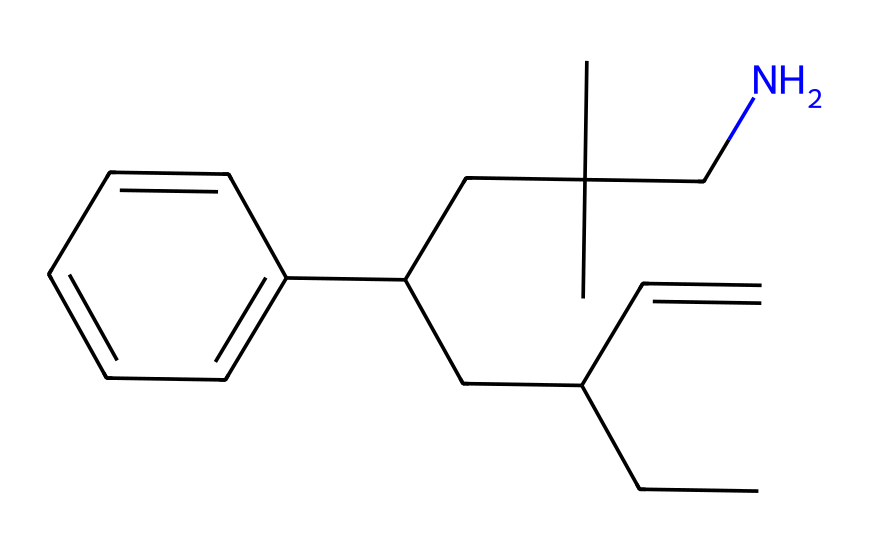What is the total number of carbon atoms in the structure? Count the number of carbon (C) symbols in the SMILES representation, which indicates all the carbon atoms present in the molecular structure. By analyzing the provided SMILES, we find a total of 16 carbon atoms.
Answer: 16 How many nitrogen atoms are present in the molecule? Look for the nitrogen (N) symbols in the SMILES representation. In the provided structure, there is one nitrogen atom present.
Answer: 1 What type of functional group is primarily represented in this structure? Examine the structure to identify the functional groups, particularly looking for double bonds or aromatic rings. The presence of alkenes (C=C) and an aromatic ring (c1ccccc1) indicates that the main functional groups in this structure are alkenes and aromatic compounds.
Answer: alkenes and aromatic How many cycles or rings are present in the molecule? Analyze the structure for any ring closures, which are indicated by the numerical identifiers in SMILES. In this case, the presence of 'c1ccccc1' indicates one cyclic structure (a benzene ring).
Answer: 1 Which part of the molecule contributes to its elasticity? Identify the segments of the molecule that could provide elastic properties, typically found in plastic materials. The butadiene portion of the ABS structure is primarily responsible for the elasticity due to its rubber-like nature.
Answer: butadiene What is the significance of the branching in this structure? Consider the impact of the branch points on the physical properties of the polymer, including strength and flexibility. The branching enhances the material's toughness and lowers its density, improving the durability and performance of the toy components made from this polymer.
Answer: enhances toughness 